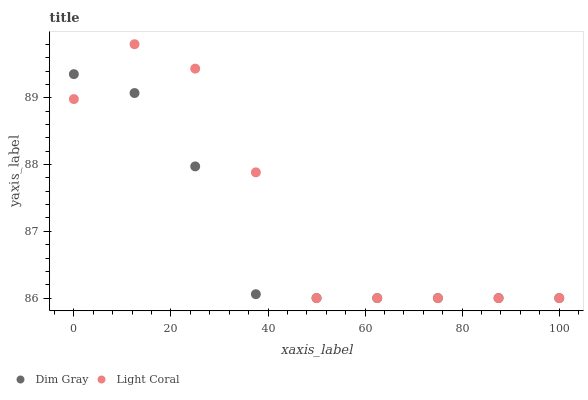Does Dim Gray have the minimum area under the curve?
Answer yes or no. Yes. Does Light Coral have the maximum area under the curve?
Answer yes or no. Yes. Does Dim Gray have the maximum area under the curve?
Answer yes or no. No. Is Dim Gray the smoothest?
Answer yes or no. Yes. Is Light Coral the roughest?
Answer yes or no. Yes. Is Dim Gray the roughest?
Answer yes or no. No. Does Light Coral have the lowest value?
Answer yes or no. Yes. Does Light Coral have the highest value?
Answer yes or no. Yes. Does Dim Gray have the highest value?
Answer yes or no. No. Does Light Coral intersect Dim Gray?
Answer yes or no. Yes. Is Light Coral less than Dim Gray?
Answer yes or no. No. Is Light Coral greater than Dim Gray?
Answer yes or no. No. 